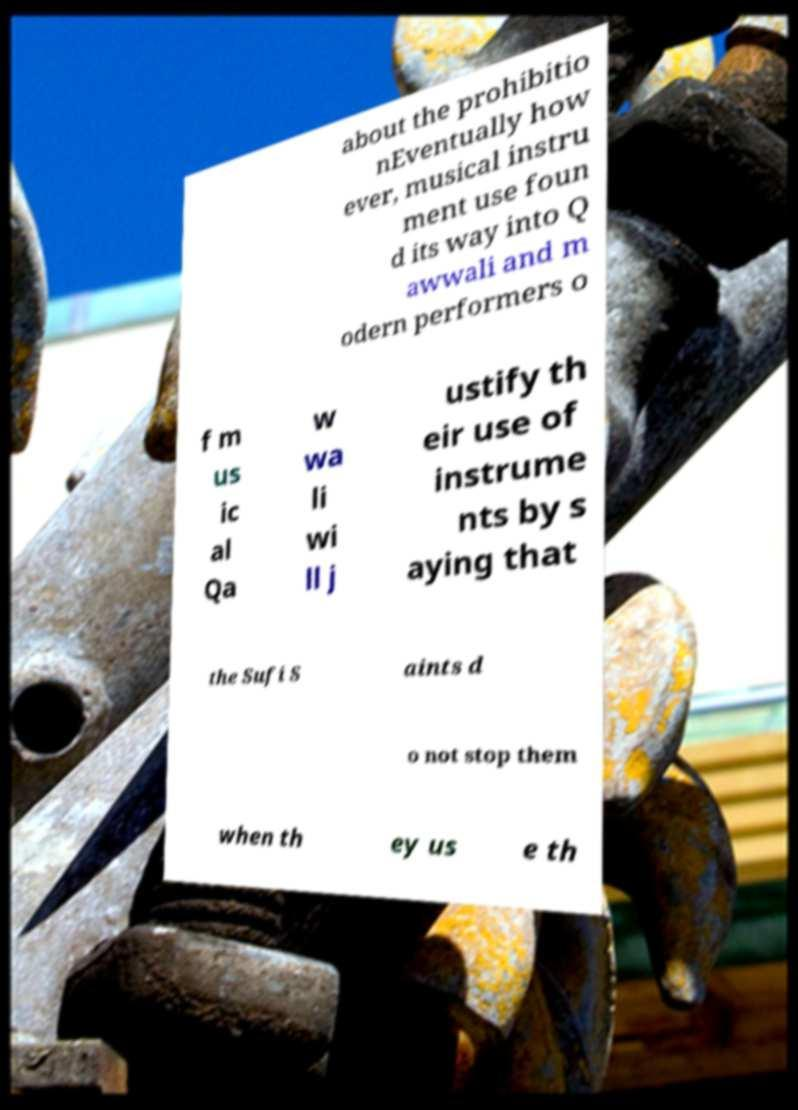Please identify and transcribe the text found in this image. about the prohibitio nEventually how ever, musical instru ment use foun d its way into Q awwali and m odern performers o f m us ic al Qa w wa li wi ll j ustify th eir use of instrume nts by s aying that the Sufi S aints d o not stop them when th ey us e th 